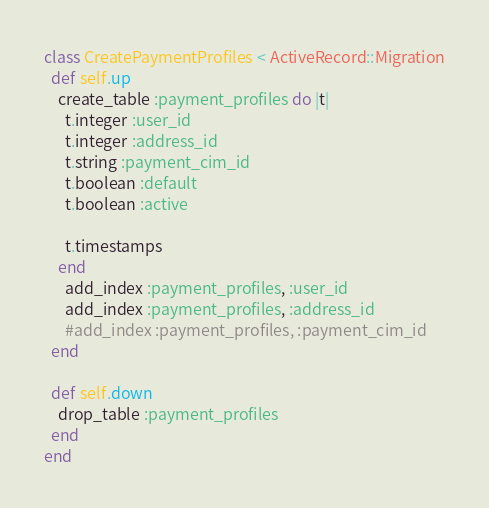Convert code to text. <code><loc_0><loc_0><loc_500><loc_500><_Ruby_>class CreatePaymentProfiles < ActiveRecord::Migration
  def self.up
    create_table :payment_profiles do |t|
      t.integer :user_id
      t.integer :address_id
      t.string :payment_cim_id
      t.boolean :default
      t.boolean :active

      t.timestamps
    end
      add_index :payment_profiles, :user_id
      add_index :payment_profiles, :address_id
      #add_index :payment_profiles, :payment_cim_id
  end

  def self.down
    drop_table :payment_profiles
  end
end
</code> 